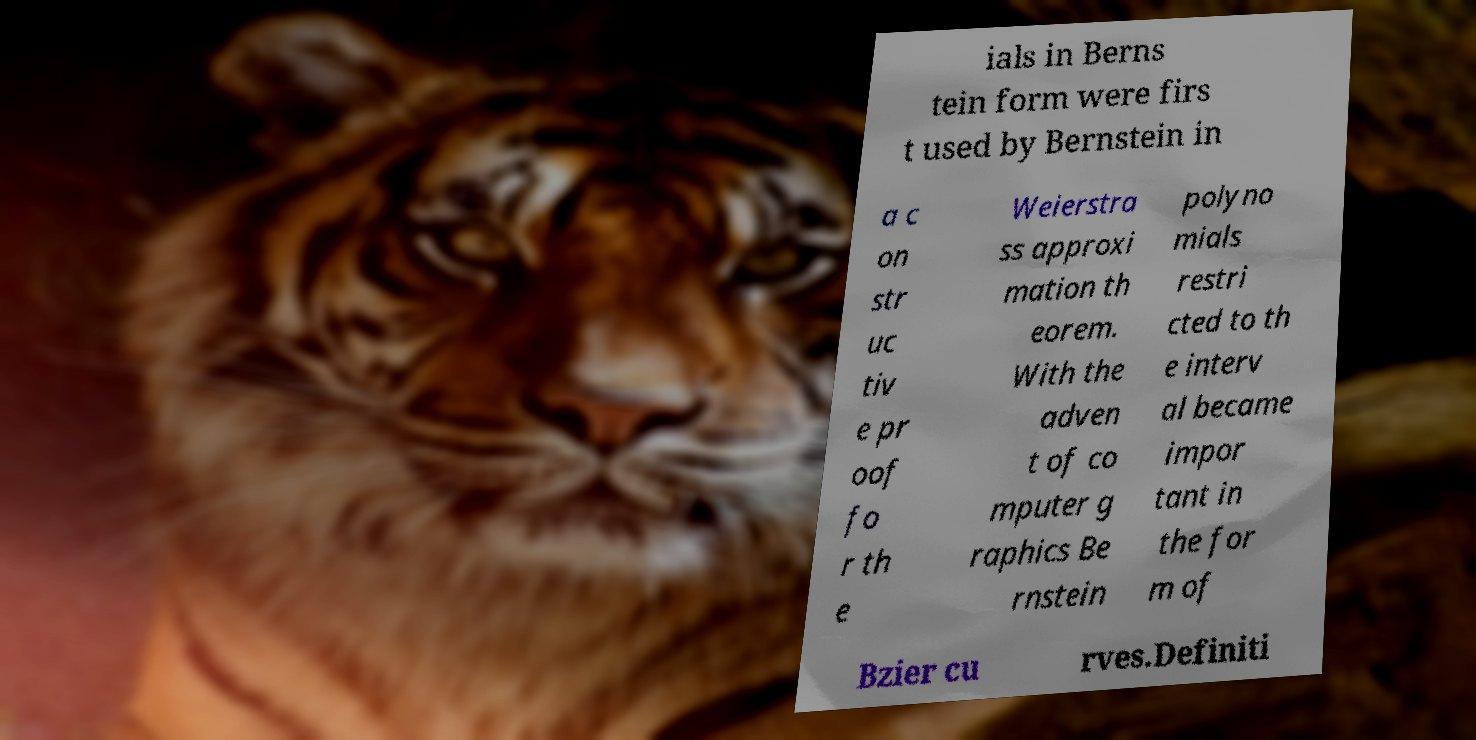Please read and relay the text visible in this image. What does it say? ials in Berns tein form were firs t used by Bernstein in a c on str uc tiv e pr oof fo r th e Weierstra ss approxi mation th eorem. With the adven t of co mputer g raphics Be rnstein polyno mials restri cted to th e interv al became impor tant in the for m of Bzier cu rves.Definiti 